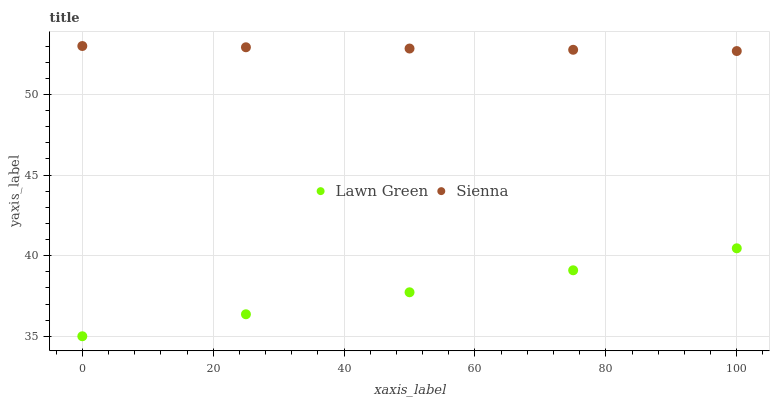Does Lawn Green have the minimum area under the curve?
Answer yes or no. Yes. Does Sienna have the maximum area under the curve?
Answer yes or no. Yes. Does Lawn Green have the maximum area under the curve?
Answer yes or no. No. Is Lawn Green the smoothest?
Answer yes or no. Yes. Is Sienna the roughest?
Answer yes or no. Yes. Is Lawn Green the roughest?
Answer yes or no. No. Does Lawn Green have the lowest value?
Answer yes or no. Yes. Does Sienna have the highest value?
Answer yes or no. Yes. Does Lawn Green have the highest value?
Answer yes or no. No. Is Lawn Green less than Sienna?
Answer yes or no. Yes. Is Sienna greater than Lawn Green?
Answer yes or no. Yes. Does Lawn Green intersect Sienna?
Answer yes or no. No. 